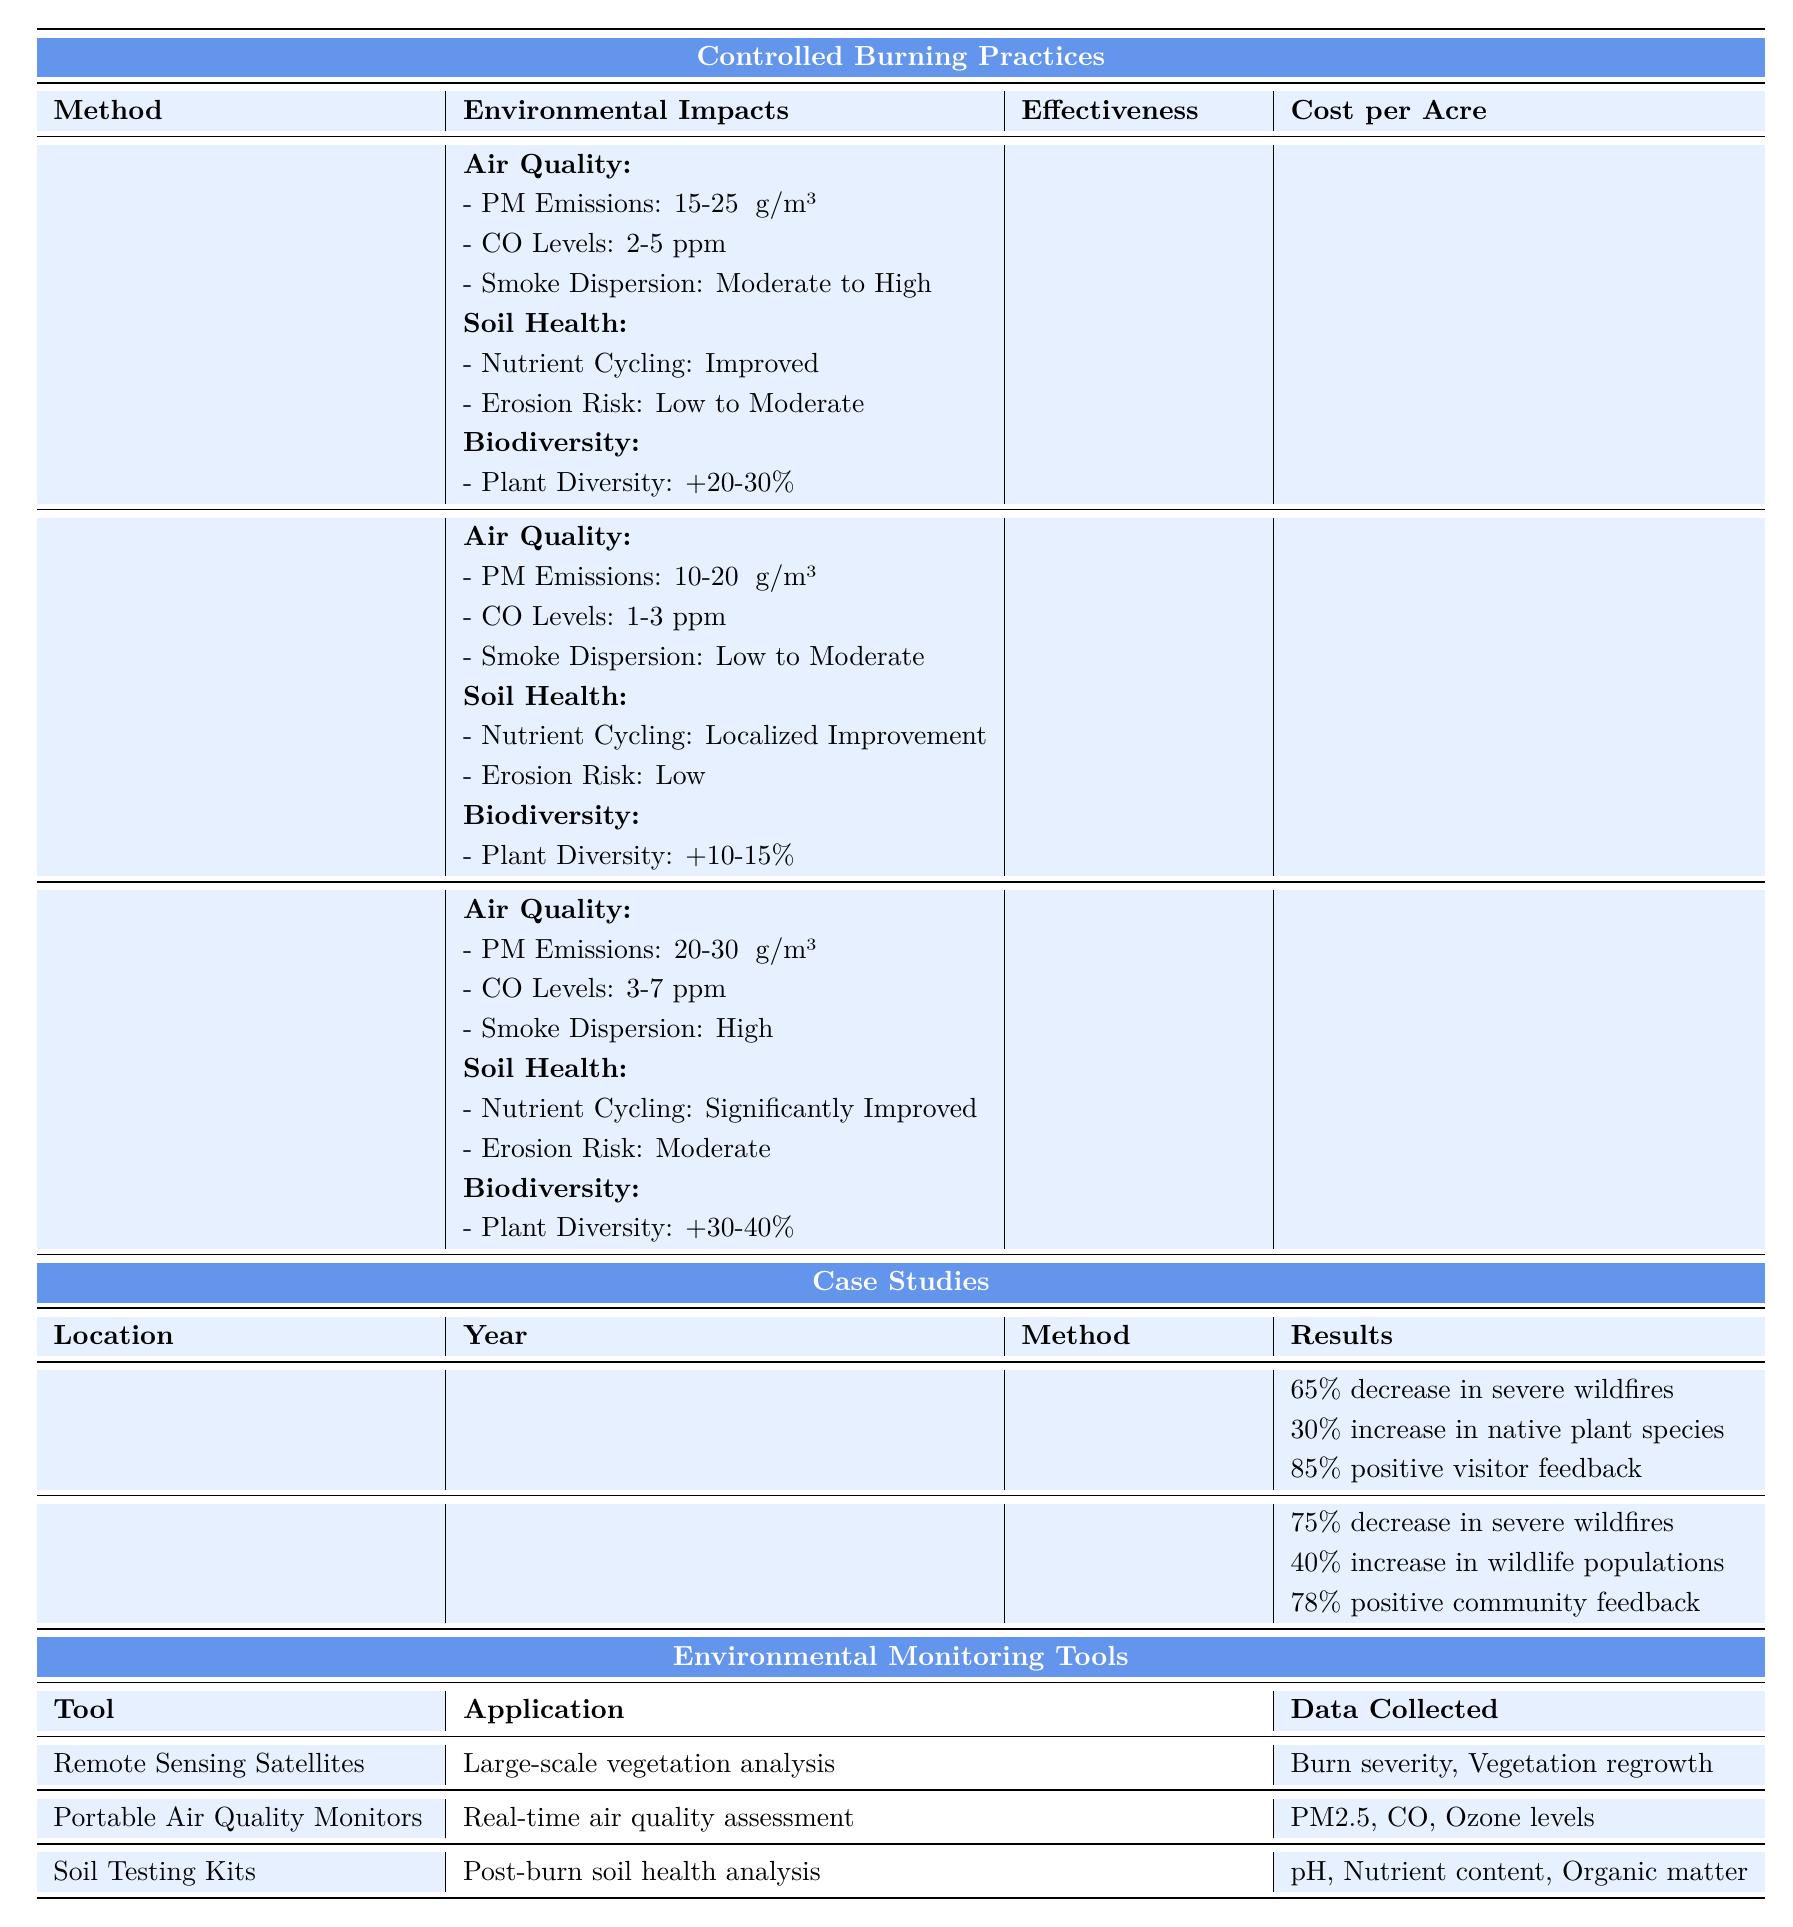What is the effectiveness of the Prescribed Burning method in wildfire prevention? According to the table, the effectiveness of the Prescribed Burning method in wildfire prevention is listed as 70-80%.
Answer: 70-80% How much does it cost per acre to implement Broadcast Burning? The table indicates that the cost per acre for Broadcast Burning ranges from $75 to $250.
Answer: $75-$250 Which method has the highest increase in plant species diversity? By comparing the biodiversity section of each method, Broadcast Burning shows an increase in plant species diversity by 30-40%, which is higher than the other methods.
Answer: Broadcast Burning Which method has the least particulate matter emissions? The table shows that Pile Burning has particulate matter emissions ranging from 10-20 μg/m³, which is less than the emissions from both Prescribed Burning and Broadcast Burning.
Answer: Pile Burning Is the Wildfire Reduction percentage for the Deschutes National Forest higher than that for Yosemite National Park? The Wildfire Reduction for Deschutes National Forest is 75%, while for Yosemite National Park it is 65%. Since 75% is greater than 65%, the statement is true.
Answer: Yes What is the average effectiveness in wildfire prevention for the three methods? The effectiveness values are 70-80% for Prescribed Burning, 50-60% for Pile Burning and 80-90% for Broadcast Burning. First, we take the midpoints: 75%, 55%, and 85% respectively. The average is (75 + 55 + 85) / 3 = 215 / 3 = 71.67%.
Answer: 71.67% Which two controlled burning methods have a temporary reduction in microbial activity? The table indicates that both Prescribed Burning and Broadcast Burning have a temporary reduction in microbial activity, followed by quick or rapid recovery respectively.
Answer: Prescribed Burning and Broadcast Burning In terms of air quality impact, which method results in the highest carbon monoxide levels? By reviewing the air quality data, Broadcast Burning has carbon monoxide levels of 3-7 ppm, which is higher than both Prescribed Burning (2-5 ppm) and Pile Burning (1-3 ppm).
Answer: Broadcast Burning What is the overall feedback percentage from visitors after the Prescribed Burning case study? The results section for the Yosemite National Park case study shows an 85% positive feedback from visitors after the Prescribed Burning method was used.
Answer: 85% Which environmental monitoring tool assesses real-time air quality? The table specifies that Portable Air Quality Monitors are used for real-time air quality assessment, collecting data on PM2.5, CO, and Ozone levels.
Answer: Portable Air Quality Monitors 